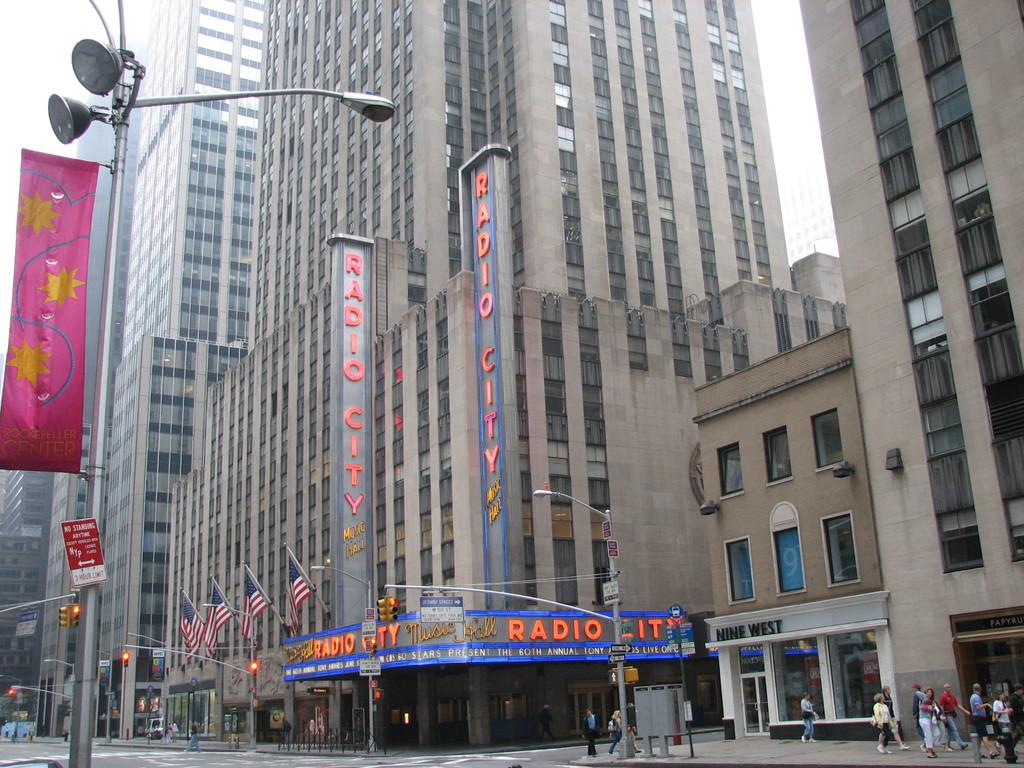What structures can be seen on the right side of the image? There are buildings, flags, and traffic signals on the right side of the image. What are the people in the image doing? People are walking on the pavement on the right side of the image. What type of lighting is present on the left side of the image? There is a street light on the left side of the image. What type of coat is draped over the street light in the image? There is no coat present in the image; the street light is not draped with any clothing. What type of sheet is covering the buildings in the image? There is no sheet present in the image; the buildings are not covered with any fabric. 